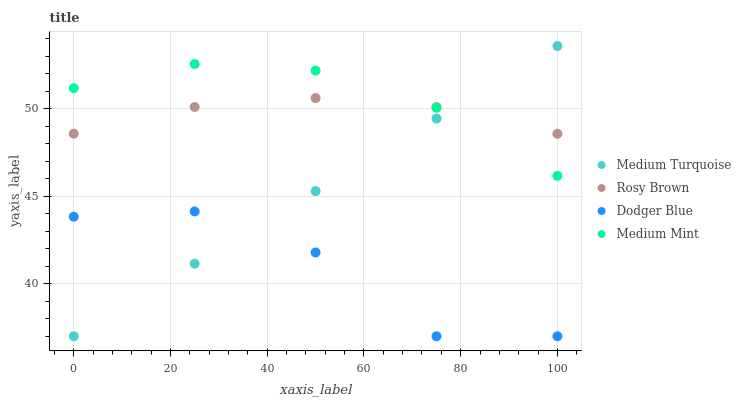Does Dodger Blue have the minimum area under the curve?
Answer yes or no. Yes. Does Medium Mint have the maximum area under the curve?
Answer yes or no. Yes. Does Rosy Brown have the minimum area under the curve?
Answer yes or no. No. Does Rosy Brown have the maximum area under the curve?
Answer yes or no. No. Is Medium Turquoise the smoothest?
Answer yes or no. Yes. Is Dodger Blue the roughest?
Answer yes or no. Yes. Is Rosy Brown the smoothest?
Answer yes or no. No. Is Rosy Brown the roughest?
Answer yes or no. No. Does Dodger Blue have the lowest value?
Answer yes or no. Yes. Does Rosy Brown have the lowest value?
Answer yes or no. No. Does Medium Turquoise have the highest value?
Answer yes or no. Yes. Does Rosy Brown have the highest value?
Answer yes or no. No. Is Dodger Blue less than Rosy Brown?
Answer yes or no. Yes. Is Rosy Brown greater than Dodger Blue?
Answer yes or no. Yes. Does Medium Turquoise intersect Rosy Brown?
Answer yes or no. Yes. Is Medium Turquoise less than Rosy Brown?
Answer yes or no. No. Is Medium Turquoise greater than Rosy Brown?
Answer yes or no. No. Does Dodger Blue intersect Rosy Brown?
Answer yes or no. No. 